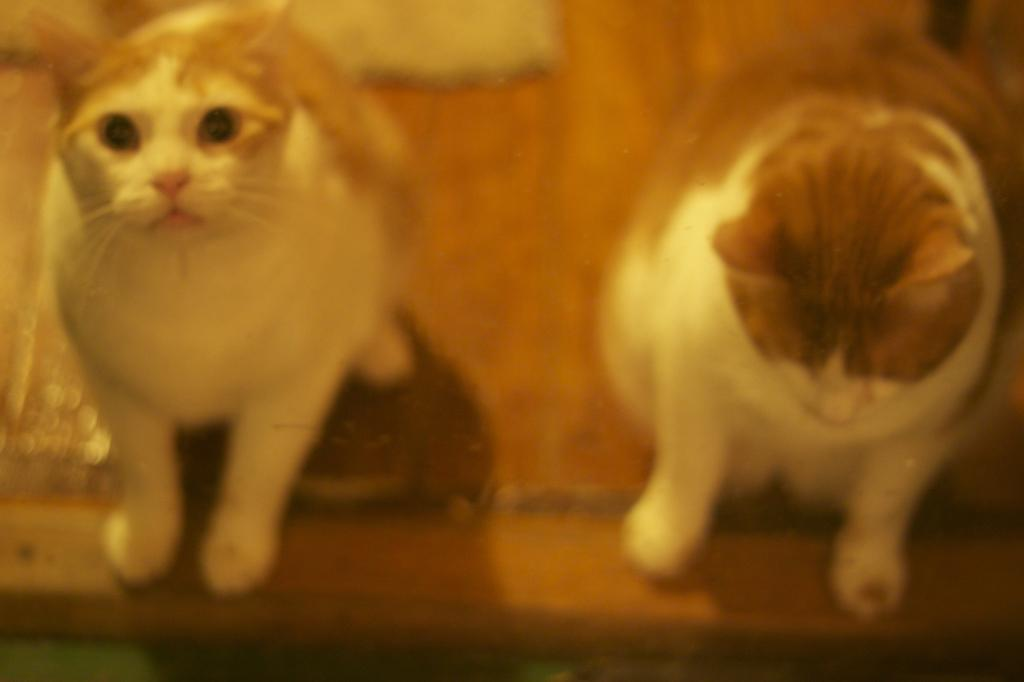What type of animals are present in the image? There are cats in the image. Where are the cats located in the image? The cats are on the floor. What type of caption is written on the balloon in the image? There is no balloon present in the image, and therefore no caption can be observed. 